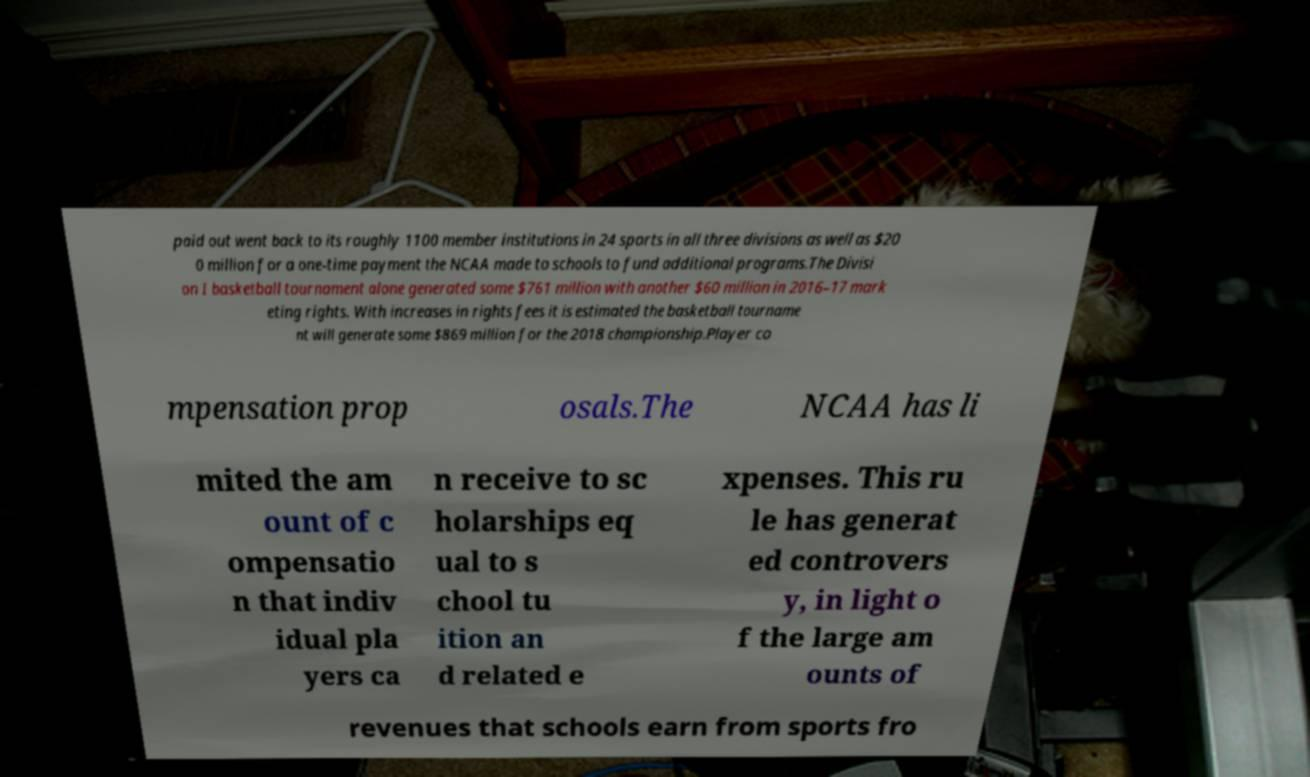Please identify and transcribe the text found in this image. paid out went back to its roughly 1100 member institutions in 24 sports in all three divisions as well as $20 0 million for a one-time payment the NCAA made to schools to fund additional programs.The Divisi on I basketball tournament alone generated some $761 million with another $60 million in 2016–17 mark eting rights. With increases in rights fees it is estimated the basketball tourname nt will generate some $869 million for the 2018 championship.Player co mpensation prop osals.The NCAA has li mited the am ount of c ompensatio n that indiv idual pla yers ca n receive to sc holarships eq ual to s chool tu ition an d related e xpenses. This ru le has generat ed controvers y, in light o f the large am ounts of revenues that schools earn from sports fro 